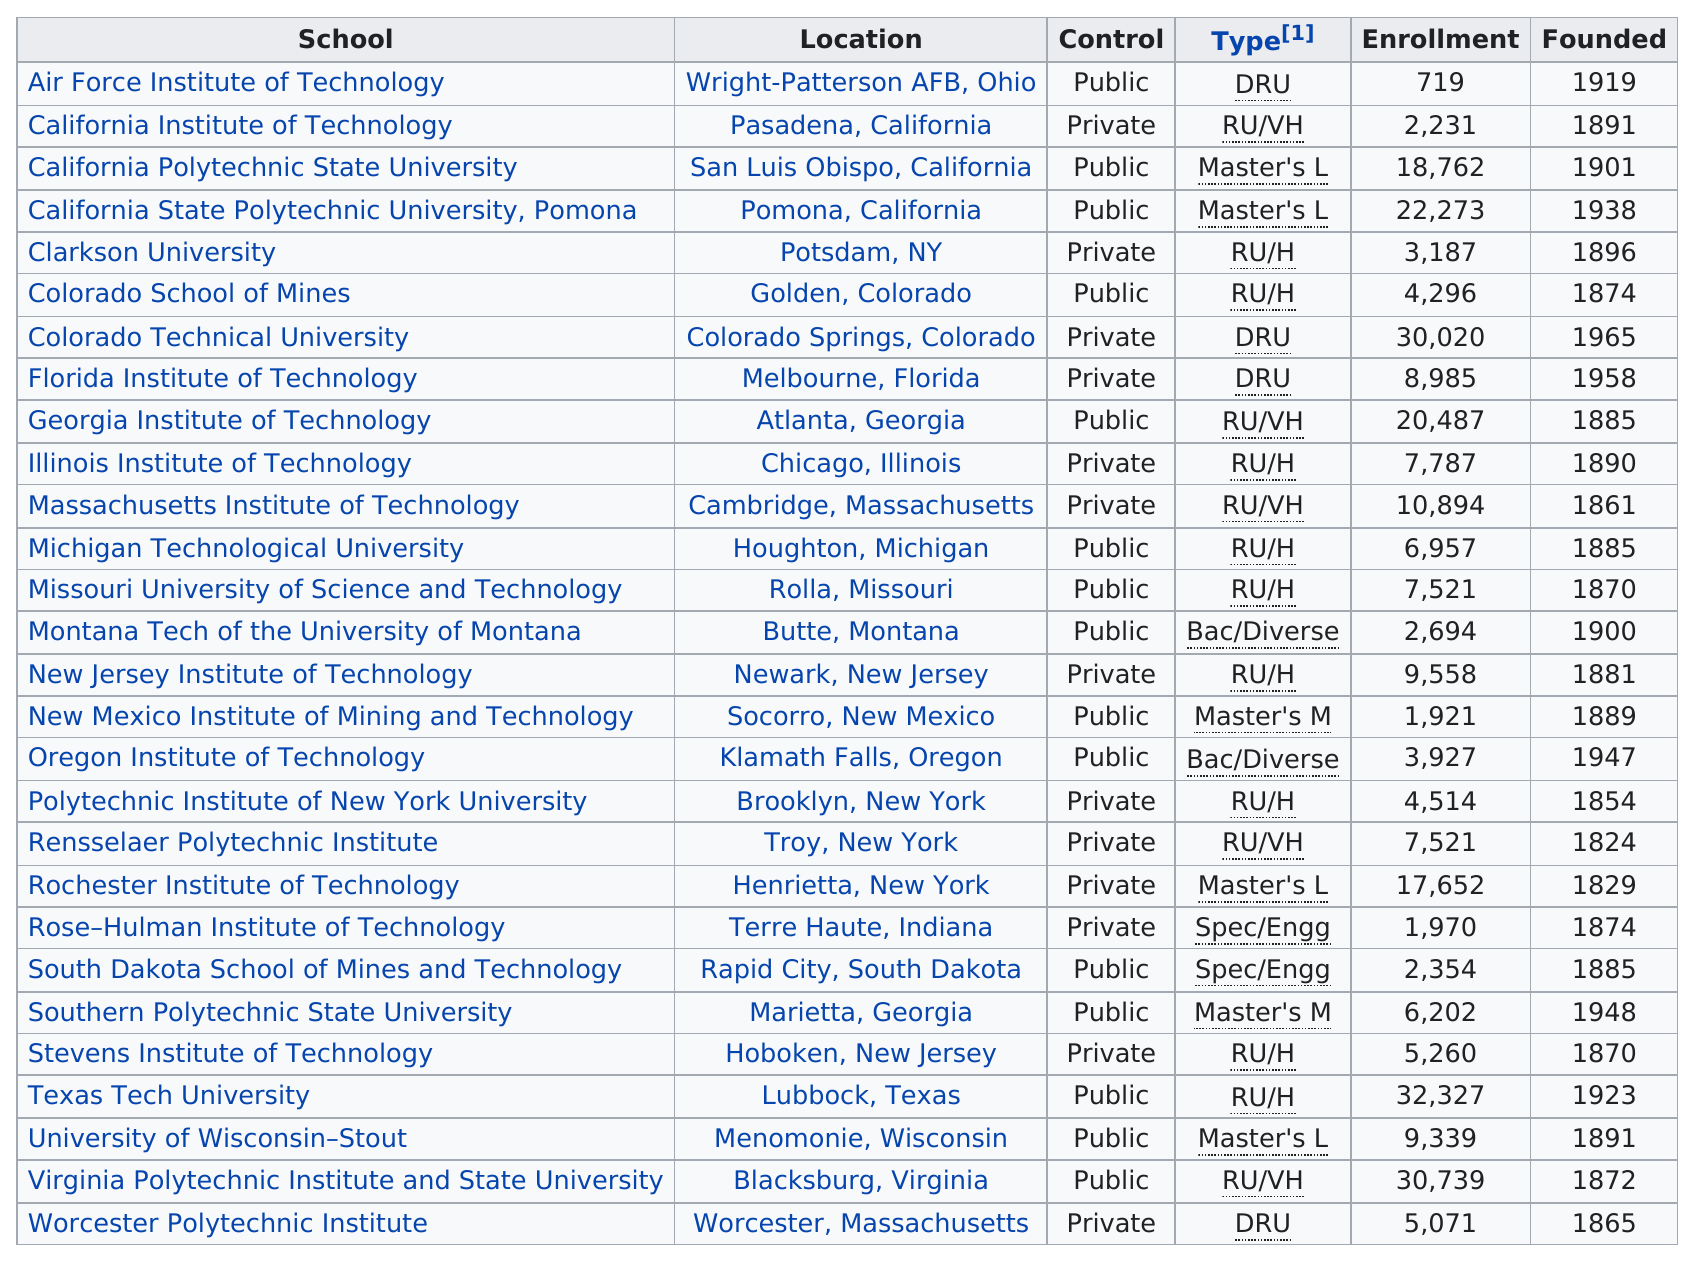Point out several critical features in this image. The difference in enrollment between the top two schools listed in the table is 1512. There are 15 US technological universities that are not private universities. According to the data, three universities were located in California. There are a total of 28 schools listed in the table. Air Force Institute of Technology has the least enrollment among all schools. 